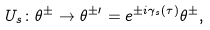<formula> <loc_0><loc_0><loc_500><loc_500>U _ { s } \colon \theta ^ { \pm } \rightarrow \theta ^ { \pm \prime } = e ^ { \pm i \gamma _ { s } ( \tau ) } \theta ^ { \pm } ,</formula> 